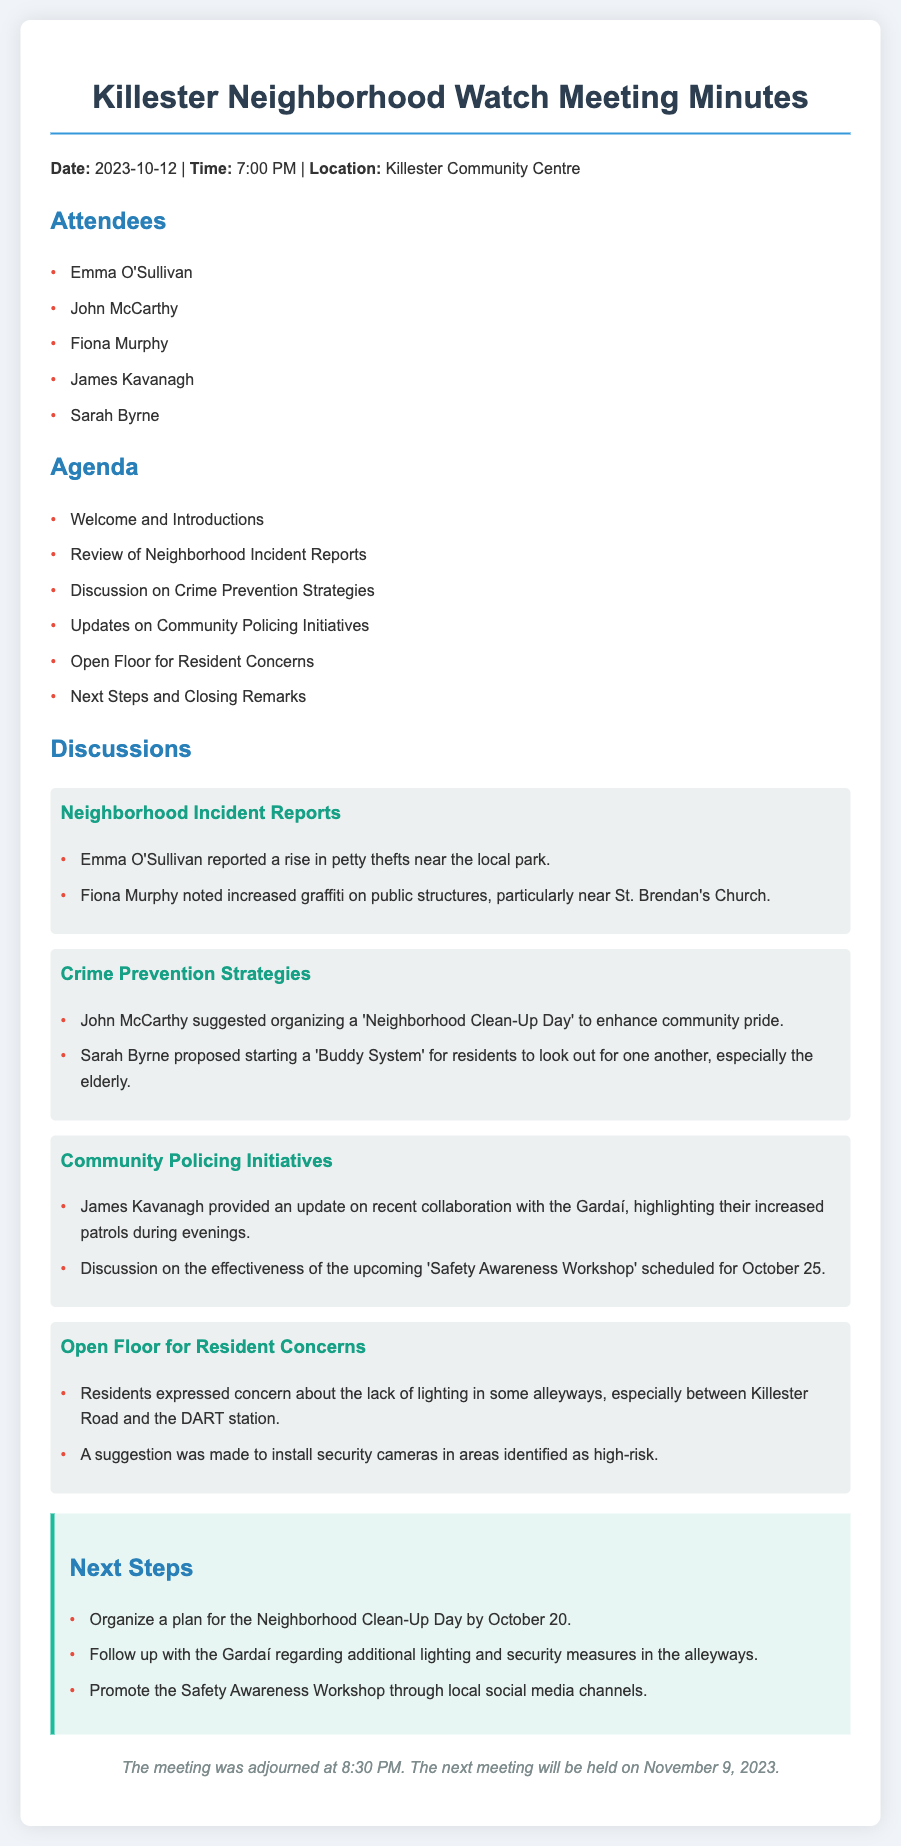what is the date of the meeting? The date of the meeting is explicitly stated in the document.
Answer: 2023-10-12 who reported a rise in petty thefts? The document specifies that Emma O'Sullivan reported this incident.
Answer: Emma O'Sullivan what is one of the concerns raised by residents? The document lists multiple resident concerns, providing insight into community issues.
Answer: Lack of lighting in some alleyways when is the next meeting scheduled? The document provides the date for the next meeting at the end of the minutes.
Answer: November 9, 2023 who suggested organizing a 'Neighborhood Clean-Up Day'? The document attributes this suggestion to a specific attendee, indicating their contribution.
Answer: John McCarthy how many attendees were present at the meeting? The list of attendees in the document gives the total number directly.
Answer: Five what strategy was proposed for the elderly residents? The document highlights a proposed strategy specifically aimed at supporting elderly residents.
Answer: Buddy System what initiative is scheduled for October 25? The document mentions an upcoming event related to community safety initiatives.
Answer: Safety Awareness Workshop what action should be taken by October 20? The document outlines a specific task that has a deadline.
Answer: Organize a plan for the Neighborhood Clean-Up Day 